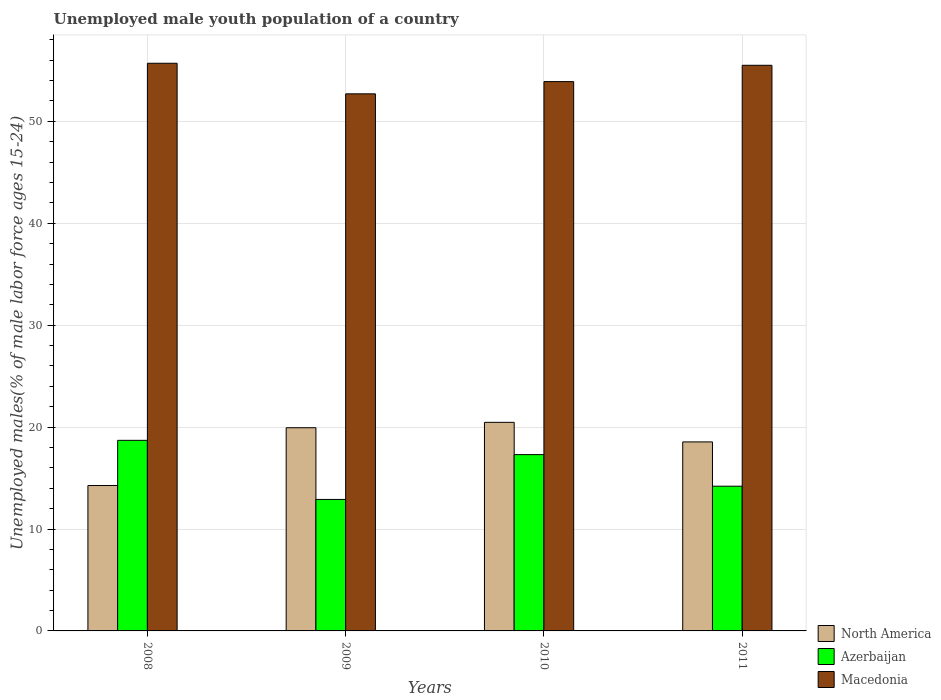How many bars are there on the 3rd tick from the left?
Make the answer very short. 3. How many bars are there on the 2nd tick from the right?
Your answer should be very brief. 3. In how many cases, is the number of bars for a given year not equal to the number of legend labels?
Offer a terse response. 0. What is the percentage of unemployed male youth population in North America in 2008?
Offer a very short reply. 14.27. Across all years, what is the maximum percentage of unemployed male youth population in Azerbaijan?
Make the answer very short. 18.7. Across all years, what is the minimum percentage of unemployed male youth population in North America?
Keep it short and to the point. 14.27. What is the total percentage of unemployed male youth population in Azerbaijan in the graph?
Your answer should be compact. 63.1. What is the difference between the percentage of unemployed male youth population in Azerbaijan in 2008 and that in 2010?
Your response must be concise. 1.4. What is the difference between the percentage of unemployed male youth population in Azerbaijan in 2008 and the percentage of unemployed male youth population in North America in 2010?
Your answer should be very brief. -1.77. What is the average percentage of unemployed male youth population in Azerbaijan per year?
Make the answer very short. 15.77. In the year 2010, what is the difference between the percentage of unemployed male youth population in Azerbaijan and percentage of unemployed male youth population in North America?
Your response must be concise. -3.17. What is the ratio of the percentage of unemployed male youth population in North America in 2009 to that in 2010?
Ensure brevity in your answer.  0.97. Is the percentage of unemployed male youth population in Azerbaijan in 2008 less than that in 2010?
Give a very brief answer. No. Is the difference between the percentage of unemployed male youth population in Azerbaijan in 2009 and 2010 greater than the difference between the percentage of unemployed male youth population in North America in 2009 and 2010?
Offer a very short reply. No. What is the difference between the highest and the second highest percentage of unemployed male youth population in Macedonia?
Offer a terse response. 0.2. What is the difference between the highest and the lowest percentage of unemployed male youth population in Azerbaijan?
Provide a succinct answer. 5.8. What does the 3rd bar from the right in 2010 represents?
Ensure brevity in your answer.  North America. How many bars are there?
Your answer should be very brief. 12. How many years are there in the graph?
Your answer should be compact. 4. Are the values on the major ticks of Y-axis written in scientific E-notation?
Ensure brevity in your answer.  No. Does the graph contain any zero values?
Give a very brief answer. No. Does the graph contain grids?
Your answer should be very brief. Yes. How are the legend labels stacked?
Provide a short and direct response. Vertical. What is the title of the graph?
Provide a succinct answer. Unemployed male youth population of a country. What is the label or title of the Y-axis?
Provide a succinct answer. Unemployed males(% of male labor force ages 15-24). What is the Unemployed males(% of male labor force ages 15-24) of North America in 2008?
Provide a short and direct response. 14.27. What is the Unemployed males(% of male labor force ages 15-24) in Azerbaijan in 2008?
Provide a short and direct response. 18.7. What is the Unemployed males(% of male labor force ages 15-24) in Macedonia in 2008?
Provide a succinct answer. 55.7. What is the Unemployed males(% of male labor force ages 15-24) in North America in 2009?
Offer a terse response. 19.94. What is the Unemployed males(% of male labor force ages 15-24) in Azerbaijan in 2009?
Keep it short and to the point. 12.9. What is the Unemployed males(% of male labor force ages 15-24) in Macedonia in 2009?
Your answer should be very brief. 52.7. What is the Unemployed males(% of male labor force ages 15-24) in North America in 2010?
Keep it short and to the point. 20.47. What is the Unemployed males(% of male labor force ages 15-24) in Azerbaijan in 2010?
Your response must be concise. 17.3. What is the Unemployed males(% of male labor force ages 15-24) of Macedonia in 2010?
Make the answer very short. 53.9. What is the Unemployed males(% of male labor force ages 15-24) of North America in 2011?
Your response must be concise. 18.55. What is the Unemployed males(% of male labor force ages 15-24) of Azerbaijan in 2011?
Your answer should be very brief. 14.2. What is the Unemployed males(% of male labor force ages 15-24) in Macedonia in 2011?
Your answer should be compact. 55.5. Across all years, what is the maximum Unemployed males(% of male labor force ages 15-24) of North America?
Keep it short and to the point. 20.47. Across all years, what is the maximum Unemployed males(% of male labor force ages 15-24) of Azerbaijan?
Your answer should be compact. 18.7. Across all years, what is the maximum Unemployed males(% of male labor force ages 15-24) of Macedonia?
Your answer should be very brief. 55.7. Across all years, what is the minimum Unemployed males(% of male labor force ages 15-24) in North America?
Provide a short and direct response. 14.27. Across all years, what is the minimum Unemployed males(% of male labor force ages 15-24) of Azerbaijan?
Offer a terse response. 12.9. Across all years, what is the minimum Unemployed males(% of male labor force ages 15-24) of Macedonia?
Give a very brief answer. 52.7. What is the total Unemployed males(% of male labor force ages 15-24) in North America in the graph?
Keep it short and to the point. 73.22. What is the total Unemployed males(% of male labor force ages 15-24) in Azerbaijan in the graph?
Offer a terse response. 63.1. What is the total Unemployed males(% of male labor force ages 15-24) in Macedonia in the graph?
Your response must be concise. 217.8. What is the difference between the Unemployed males(% of male labor force ages 15-24) in North America in 2008 and that in 2009?
Keep it short and to the point. -5.67. What is the difference between the Unemployed males(% of male labor force ages 15-24) of Macedonia in 2008 and that in 2009?
Provide a succinct answer. 3. What is the difference between the Unemployed males(% of male labor force ages 15-24) of North America in 2008 and that in 2010?
Offer a very short reply. -6.2. What is the difference between the Unemployed males(% of male labor force ages 15-24) of Azerbaijan in 2008 and that in 2010?
Offer a very short reply. 1.4. What is the difference between the Unemployed males(% of male labor force ages 15-24) of North America in 2008 and that in 2011?
Your answer should be very brief. -4.28. What is the difference between the Unemployed males(% of male labor force ages 15-24) in Azerbaijan in 2008 and that in 2011?
Give a very brief answer. 4.5. What is the difference between the Unemployed males(% of male labor force ages 15-24) of North America in 2009 and that in 2010?
Provide a succinct answer. -0.53. What is the difference between the Unemployed males(% of male labor force ages 15-24) of Azerbaijan in 2009 and that in 2010?
Give a very brief answer. -4.4. What is the difference between the Unemployed males(% of male labor force ages 15-24) in North America in 2009 and that in 2011?
Offer a terse response. 1.39. What is the difference between the Unemployed males(% of male labor force ages 15-24) of Azerbaijan in 2009 and that in 2011?
Make the answer very short. -1.3. What is the difference between the Unemployed males(% of male labor force ages 15-24) in North America in 2010 and that in 2011?
Make the answer very short. 1.92. What is the difference between the Unemployed males(% of male labor force ages 15-24) of North America in 2008 and the Unemployed males(% of male labor force ages 15-24) of Azerbaijan in 2009?
Offer a terse response. 1.37. What is the difference between the Unemployed males(% of male labor force ages 15-24) of North America in 2008 and the Unemployed males(% of male labor force ages 15-24) of Macedonia in 2009?
Make the answer very short. -38.43. What is the difference between the Unemployed males(% of male labor force ages 15-24) of Azerbaijan in 2008 and the Unemployed males(% of male labor force ages 15-24) of Macedonia in 2009?
Your answer should be very brief. -34. What is the difference between the Unemployed males(% of male labor force ages 15-24) in North America in 2008 and the Unemployed males(% of male labor force ages 15-24) in Azerbaijan in 2010?
Your answer should be very brief. -3.03. What is the difference between the Unemployed males(% of male labor force ages 15-24) of North America in 2008 and the Unemployed males(% of male labor force ages 15-24) of Macedonia in 2010?
Offer a terse response. -39.63. What is the difference between the Unemployed males(% of male labor force ages 15-24) in Azerbaijan in 2008 and the Unemployed males(% of male labor force ages 15-24) in Macedonia in 2010?
Ensure brevity in your answer.  -35.2. What is the difference between the Unemployed males(% of male labor force ages 15-24) in North America in 2008 and the Unemployed males(% of male labor force ages 15-24) in Azerbaijan in 2011?
Provide a succinct answer. 0.07. What is the difference between the Unemployed males(% of male labor force ages 15-24) in North America in 2008 and the Unemployed males(% of male labor force ages 15-24) in Macedonia in 2011?
Your answer should be very brief. -41.23. What is the difference between the Unemployed males(% of male labor force ages 15-24) in Azerbaijan in 2008 and the Unemployed males(% of male labor force ages 15-24) in Macedonia in 2011?
Offer a very short reply. -36.8. What is the difference between the Unemployed males(% of male labor force ages 15-24) of North America in 2009 and the Unemployed males(% of male labor force ages 15-24) of Azerbaijan in 2010?
Offer a very short reply. 2.64. What is the difference between the Unemployed males(% of male labor force ages 15-24) of North America in 2009 and the Unemployed males(% of male labor force ages 15-24) of Macedonia in 2010?
Your answer should be very brief. -33.96. What is the difference between the Unemployed males(% of male labor force ages 15-24) in Azerbaijan in 2009 and the Unemployed males(% of male labor force ages 15-24) in Macedonia in 2010?
Provide a succinct answer. -41. What is the difference between the Unemployed males(% of male labor force ages 15-24) in North America in 2009 and the Unemployed males(% of male labor force ages 15-24) in Azerbaijan in 2011?
Your response must be concise. 5.74. What is the difference between the Unemployed males(% of male labor force ages 15-24) of North America in 2009 and the Unemployed males(% of male labor force ages 15-24) of Macedonia in 2011?
Your response must be concise. -35.56. What is the difference between the Unemployed males(% of male labor force ages 15-24) of Azerbaijan in 2009 and the Unemployed males(% of male labor force ages 15-24) of Macedonia in 2011?
Provide a short and direct response. -42.6. What is the difference between the Unemployed males(% of male labor force ages 15-24) of North America in 2010 and the Unemployed males(% of male labor force ages 15-24) of Azerbaijan in 2011?
Provide a succinct answer. 6.27. What is the difference between the Unemployed males(% of male labor force ages 15-24) in North America in 2010 and the Unemployed males(% of male labor force ages 15-24) in Macedonia in 2011?
Offer a terse response. -35.03. What is the difference between the Unemployed males(% of male labor force ages 15-24) of Azerbaijan in 2010 and the Unemployed males(% of male labor force ages 15-24) of Macedonia in 2011?
Keep it short and to the point. -38.2. What is the average Unemployed males(% of male labor force ages 15-24) of North America per year?
Your response must be concise. 18.3. What is the average Unemployed males(% of male labor force ages 15-24) of Azerbaijan per year?
Offer a terse response. 15.78. What is the average Unemployed males(% of male labor force ages 15-24) of Macedonia per year?
Offer a terse response. 54.45. In the year 2008, what is the difference between the Unemployed males(% of male labor force ages 15-24) of North America and Unemployed males(% of male labor force ages 15-24) of Azerbaijan?
Your answer should be compact. -4.43. In the year 2008, what is the difference between the Unemployed males(% of male labor force ages 15-24) of North America and Unemployed males(% of male labor force ages 15-24) of Macedonia?
Make the answer very short. -41.43. In the year 2008, what is the difference between the Unemployed males(% of male labor force ages 15-24) in Azerbaijan and Unemployed males(% of male labor force ages 15-24) in Macedonia?
Provide a succinct answer. -37. In the year 2009, what is the difference between the Unemployed males(% of male labor force ages 15-24) in North America and Unemployed males(% of male labor force ages 15-24) in Azerbaijan?
Your answer should be compact. 7.04. In the year 2009, what is the difference between the Unemployed males(% of male labor force ages 15-24) of North America and Unemployed males(% of male labor force ages 15-24) of Macedonia?
Make the answer very short. -32.76. In the year 2009, what is the difference between the Unemployed males(% of male labor force ages 15-24) in Azerbaijan and Unemployed males(% of male labor force ages 15-24) in Macedonia?
Provide a succinct answer. -39.8. In the year 2010, what is the difference between the Unemployed males(% of male labor force ages 15-24) of North America and Unemployed males(% of male labor force ages 15-24) of Azerbaijan?
Offer a very short reply. 3.17. In the year 2010, what is the difference between the Unemployed males(% of male labor force ages 15-24) of North America and Unemployed males(% of male labor force ages 15-24) of Macedonia?
Offer a terse response. -33.43. In the year 2010, what is the difference between the Unemployed males(% of male labor force ages 15-24) in Azerbaijan and Unemployed males(% of male labor force ages 15-24) in Macedonia?
Provide a succinct answer. -36.6. In the year 2011, what is the difference between the Unemployed males(% of male labor force ages 15-24) of North America and Unemployed males(% of male labor force ages 15-24) of Azerbaijan?
Ensure brevity in your answer.  4.35. In the year 2011, what is the difference between the Unemployed males(% of male labor force ages 15-24) of North America and Unemployed males(% of male labor force ages 15-24) of Macedonia?
Offer a very short reply. -36.95. In the year 2011, what is the difference between the Unemployed males(% of male labor force ages 15-24) of Azerbaijan and Unemployed males(% of male labor force ages 15-24) of Macedonia?
Your answer should be very brief. -41.3. What is the ratio of the Unemployed males(% of male labor force ages 15-24) of North America in 2008 to that in 2009?
Provide a succinct answer. 0.72. What is the ratio of the Unemployed males(% of male labor force ages 15-24) in Azerbaijan in 2008 to that in 2009?
Your answer should be compact. 1.45. What is the ratio of the Unemployed males(% of male labor force ages 15-24) in Macedonia in 2008 to that in 2009?
Provide a succinct answer. 1.06. What is the ratio of the Unemployed males(% of male labor force ages 15-24) of North America in 2008 to that in 2010?
Give a very brief answer. 0.7. What is the ratio of the Unemployed males(% of male labor force ages 15-24) in Azerbaijan in 2008 to that in 2010?
Give a very brief answer. 1.08. What is the ratio of the Unemployed males(% of male labor force ages 15-24) in Macedonia in 2008 to that in 2010?
Your answer should be very brief. 1.03. What is the ratio of the Unemployed males(% of male labor force ages 15-24) in North America in 2008 to that in 2011?
Offer a very short reply. 0.77. What is the ratio of the Unemployed males(% of male labor force ages 15-24) in Azerbaijan in 2008 to that in 2011?
Provide a succinct answer. 1.32. What is the ratio of the Unemployed males(% of male labor force ages 15-24) of North America in 2009 to that in 2010?
Offer a very short reply. 0.97. What is the ratio of the Unemployed males(% of male labor force ages 15-24) in Azerbaijan in 2009 to that in 2010?
Your response must be concise. 0.75. What is the ratio of the Unemployed males(% of male labor force ages 15-24) of Macedonia in 2009 to that in 2010?
Give a very brief answer. 0.98. What is the ratio of the Unemployed males(% of male labor force ages 15-24) in North America in 2009 to that in 2011?
Keep it short and to the point. 1.08. What is the ratio of the Unemployed males(% of male labor force ages 15-24) in Azerbaijan in 2009 to that in 2011?
Your answer should be very brief. 0.91. What is the ratio of the Unemployed males(% of male labor force ages 15-24) in Macedonia in 2009 to that in 2011?
Your answer should be compact. 0.95. What is the ratio of the Unemployed males(% of male labor force ages 15-24) in North America in 2010 to that in 2011?
Make the answer very short. 1.1. What is the ratio of the Unemployed males(% of male labor force ages 15-24) of Azerbaijan in 2010 to that in 2011?
Give a very brief answer. 1.22. What is the ratio of the Unemployed males(% of male labor force ages 15-24) in Macedonia in 2010 to that in 2011?
Give a very brief answer. 0.97. What is the difference between the highest and the second highest Unemployed males(% of male labor force ages 15-24) of North America?
Your answer should be very brief. 0.53. What is the difference between the highest and the second highest Unemployed males(% of male labor force ages 15-24) in Azerbaijan?
Offer a terse response. 1.4. What is the difference between the highest and the second highest Unemployed males(% of male labor force ages 15-24) of Macedonia?
Provide a short and direct response. 0.2. What is the difference between the highest and the lowest Unemployed males(% of male labor force ages 15-24) of North America?
Offer a very short reply. 6.2. What is the difference between the highest and the lowest Unemployed males(% of male labor force ages 15-24) in Azerbaijan?
Give a very brief answer. 5.8. What is the difference between the highest and the lowest Unemployed males(% of male labor force ages 15-24) in Macedonia?
Your response must be concise. 3. 